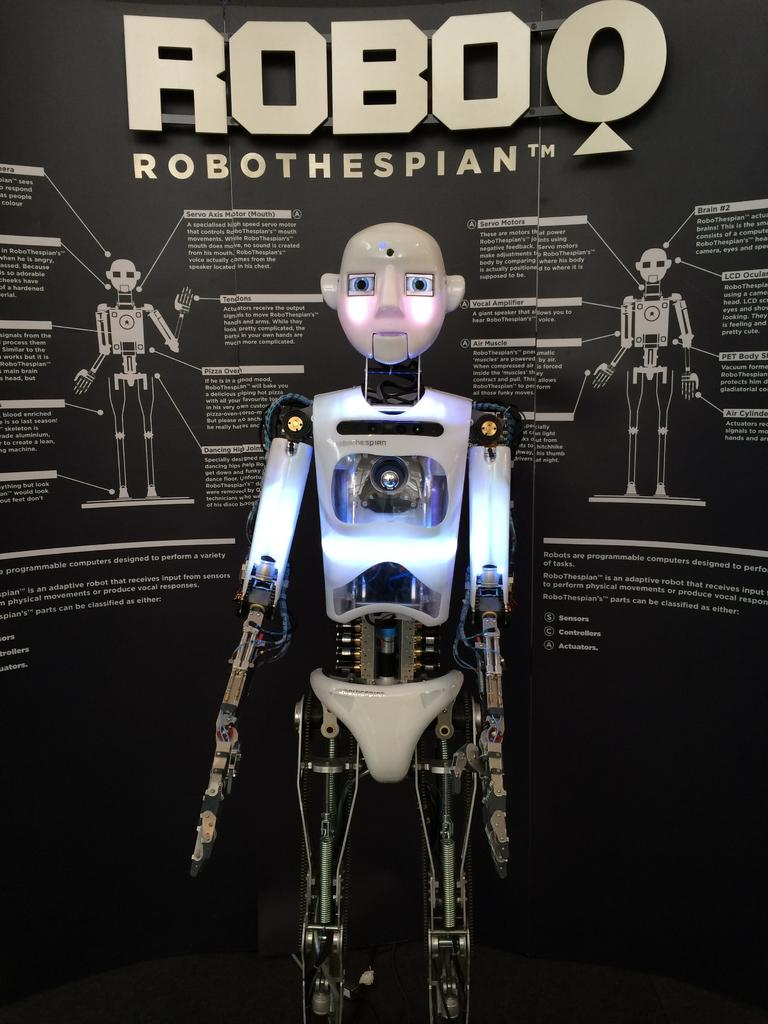What is the main subject in the image? There is a robot in the image. What can be seen on the wall behind the robot? There is a logo and some text on the wall behind the robot. What type of cast can be seen on the robot's arm in the image? There is no cast visible on the robot's arm in the image. What type of business is being advertised by the logo on the wall behind the robot? The image does not provide enough information to determine the type of business being advertised by the logo. 